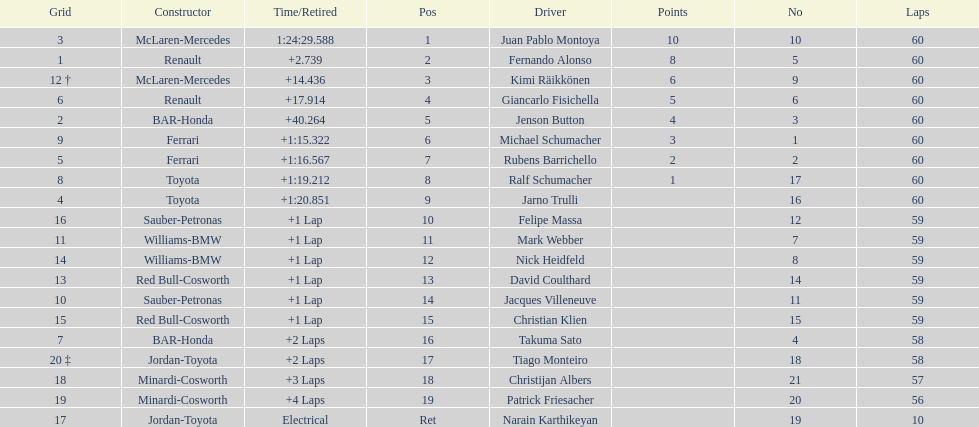Which driver came after giancarlo fisichella? Jenson Button. 